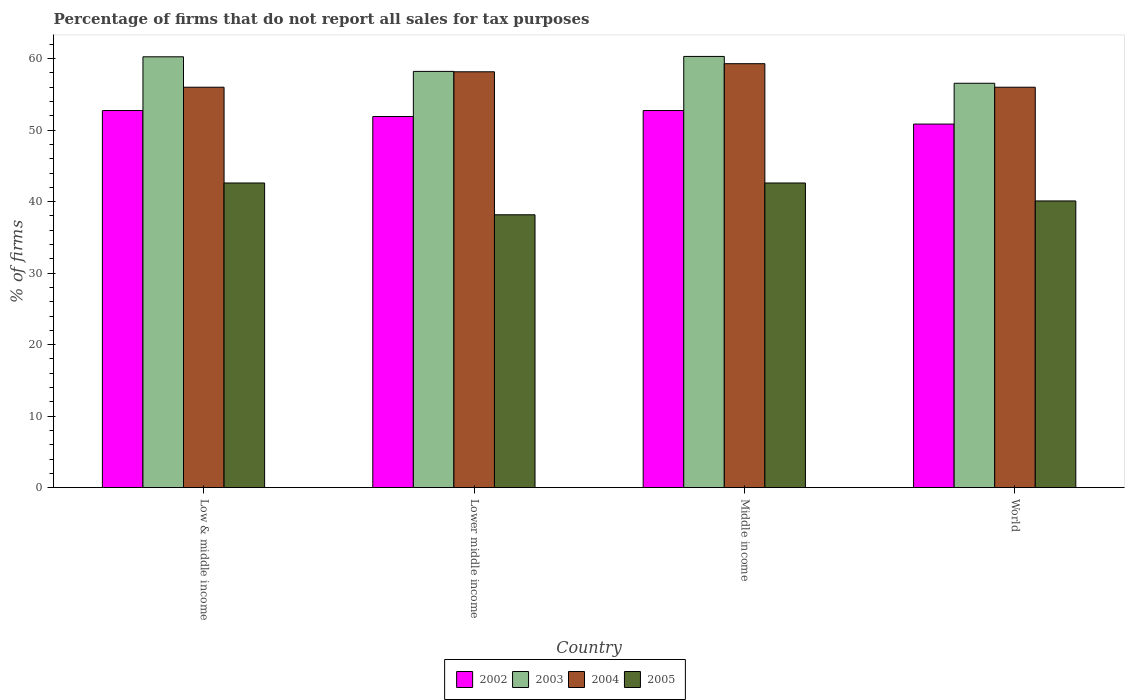How many groups of bars are there?
Ensure brevity in your answer.  4. Are the number of bars per tick equal to the number of legend labels?
Ensure brevity in your answer.  Yes. Are the number of bars on each tick of the X-axis equal?
Keep it short and to the point. Yes. How many bars are there on the 4th tick from the left?
Provide a short and direct response. 4. What is the label of the 2nd group of bars from the left?
Offer a very short reply. Lower middle income. In how many cases, is the number of bars for a given country not equal to the number of legend labels?
Your response must be concise. 0. What is the percentage of firms that do not report all sales for tax purposes in 2002 in Low & middle income?
Your answer should be very brief. 52.75. Across all countries, what is the maximum percentage of firms that do not report all sales for tax purposes in 2004?
Your answer should be compact. 59.3. Across all countries, what is the minimum percentage of firms that do not report all sales for tax purposes in 2004?
Provide a succinct answer. 56.01. In which country was the percentage of firms that do not report all sales for tax purposes in 2005 maximum?
Provide a short and direct response. Low & middle income. In which country was the percentage of firms that do not report all sales for tax purposes in 2004 minimum?
Your answer should be very brief. Low & middle income. What is the total percentage of firms that do not report all sales for tax purposes in 2003 in the graph?
Your answer should be compact. 235.35. What is the difference between the percentage of firms that do not report all sales for tax purposes in 2005 in Low & middle income and that in Middle income?
Provide a short and direct response. 0. What is the difference between the percentage of firms that do not report all sales for tax purposes in 2004 in Low & middle income and the percentage of firms that do not report all sales for tax purposes in 2003 in World?
Give a very brief answer. -0.55. What is the average percentage of firms that do not report all sales for tax purposes in 2002 per country?
Offer a very short reply. 52.06. What is the difference between the percentage of firms that do not report all sales for tax purposes of/in 2003 and percentage of firms that do not report all sales for tax purposes of/in 2002 in Lower middle income?
Your answer should be very brief. 6.31. In how many countries, is the percentage of firms that do not report all sales for tax purposes in 2005 greater than 20 %?
Your answer should be very brief. 4. What is the ratio of the percentage of firms that do not report all sales for tax purposes in 2002 in Lower middle income to that in Middle income?
Offer a very short reply. 0.98. Is the percentage of firms that do not report all sales for tax purposes in 2003 in Middle income less than that in World?
Keep it short and to the point. No. Is the difference between the percentage of firms that do not report all sales for tax purposes in 2003 in Middle income and World greater than the difference between the percentage of firms that do not report all sales for tax purposes in 2002 in Middle income and World?
Ensure brevity in your answer.  Yes. What is the difference between the highest and the second highest percentage of firms that do not report all sales for tax purposes in 2004?
Make the answer very short. -2.16. What is the difference between the highest and the lowest percentage of firms that do not report all sales for tax purposes in 2002?
Provide a short and direct response. 1.89. Is the sum of the percentage of firms that do not report all sales for tax purposes in 2005 in Low & middle income and Lower middle income greater than the maximum percentage of firms that do not report all sales for tax purposes in 2004 across all countries?
Offer a very short reply. Yes. Is it the case that in every country, the sum of the percentage of firms that do not report all sales for tax purposes in 2002 and percentage of firms that do not report all sales for tax purposes in 2005 is greater than the percentage of firms that do not report all sales for tax purposes in 2004?
Your answer should be very brief. Yes. How many bars are there?
Provide a succinct answer. 16. Does the graph contain grids?
Ensure brevity in your answer.  No. What is the title of the graph?
Keep it short and to the point. Percentage of firms that do not report all sales for tax purposes. Does "2001" appear as one of the legend labels in the graph?
Ensure brevity in your answer.  No. What is the label or title of the Y-axis?
Give a very brief answer. % of firms. What is the % of firms in 2002 in Low & middle income?
Your response must be concise. 52.75. What is the % of firms of 2003 in Low & middle income?
Your answer should be compact. 60.26. What is the % of firms of 2004 in Low & middle income?
Your answer should be very brief. 56.01. What is the % of firms in 2005 in Low & middle income?
Give a very brief answer. 42.61. What is the % of firms of 2002 in Lower middle income?
Your answer should be very brief. 51.91. What is the % of firms of 2003 in Lower middle income?
Offer a terse response. 58.22. What is the % of firms in 2004 in Lower middle income?
Your response must be concise. 58.16. What is the % of firms in 2005 in Lower middle income?
Keep it short and to the point. 38.16. What is the % of firms in 2002 in Middle income?
Your answer should be very brief. 52.75. What is the % of firms of 2003 in Middle income?
Ensure brevity in your answer.  60.31. What is the % of firms of 2004 in Middle income?
Your answer should be compact. 59.3. What is the % of firms in 2005 in Middle income?
Make the answer very short. 42.61. What is the % of firms of 2002 in World?
Keep it short and to the point. 50.85. What is the % of firms in 2003 in World?
Provide a succinct answer. 56.56. What is the % of firms in 2004 in World?
Ensure brevity in your answer.  56.01. What is the % of firms in 2005 in World?
Offer a terse response. 40.1. Across all countries, what is the maximum % of firms of 2002?
Your answer should be compact. 52.75. Across all countries, what is the maximum % of firms in 2003?
Your response must be concise. 60.31. Across all countries, what is the maximum % of firms in 2004?
Your answer should be compact. 59.3. Across all countries, what is the maximum % of firms of 2005?
Keep it short and to the point. 42.61. Across all countries, what is the minimum % of firms of 2002?
Your answer should be very brief. 50.85. Across all countries, what is the minimum % of firms of 2003?
Offer a very short reply. 56.56. Across all countries, what is the minimum % of firms of 2004?
Offer a very short reply. 56.01. Across all countries, what is the minimum % of firms in 2005?
Keep it short and to the point. 38.16. What is the total % of firms in 2002 in the graph?
Offer a terse response. 208.25. What is the total % of firms of 2003 in the graph?
Provide a succinct answer. 235.35. What is the total % of firms of 2004 in the graph?
Your response must be concise. 229.47. What is the total % of firms of 2005 in the graph?
Give a very brief answer. 163.48. What is the difference between the % of firms in 2002 in Low & middle income and that in Lower middle income?
Ensure brevity in your answer.  0.84. What is the difference between the % of firms in 2003 in Low & middle income and that in Lower middle income?
Give a very brief answer. 2.04. What is the difference between the % of firms of 2004 in Low & middle income and that in Lower middle income?
Provide a succinct answer. -2.16. What is the difference between the % of firms in 2005 in Low & middle income and that in Lower middle income?
Keep it short and to the point. 4.45. What is the difference between the % of firms in 2002 in Low & middle income and that in Middle income?
Offer a terse response. 0. What is the difference between the % of firms of 2003 in Low & middle income and that in Middle income?
Give a very brief answer. -0.05. What is the difference between the % of firms in 2004 in Low & middle income and that in Middle income?
Ensure brevity in your answer.  -3.29. What is the difference between the % of firms of 2005 in Low & middle income and that in Middle income?
Your response must be concise. 0. What is the difference between the % of firms in 2002 in Low & middle income and that in World?
Make the answer very short. 1.89. What is the difference between the % of firms of 2005 in Low & middle income and that in World?
Make the answer very short. 2.51. What is the difference between the % of firms of 2002 in Lower middle income and that in Middle income?
Keep it short and to the point. -0.84. What is the difference between the % of firms in 2003 in Lower middle income and that in Middle income?
Offer a very short reply. -2.09. What is the difference between the % of firms of 2004 in Lower middle income and that in Middle income?
Your answer should be very brief. -1.13. What is the difference between the % of firms in 2005 in Lower middle income and that in Middle income?
Make the answer very short. -4.45. What is the difference between the % of firms of 2002 in Lower middle income and that in World?
Offer a very short reply. 1.06. What is the difference between the % of firms of 2003 in Lower middle income and that in World?
Provide a short and direct response. 1.66. What is the difference between the % of firms in 2004 in Lower middle income and that in World?
Ensure brevity in your answer.  2.16. What is the difference between the % of firms of 2005 in Lower middle income and that in World?
Provide a short and direct response. -1.94. What is the difference between the % of firms in 2002 in Middle income and that in World?
Offer a terse response. 1.89. What is the difference between the % of firms of 2003 in Middle income and that in World?
Keep it short and to the point. 3.75. What is the difference between the % of firms of 2004 in Middle income and that in World?
Keep it short and to the point. 3.29. What is the difference between the % of firms in 2005 in Middle income and that in World?
Make the answer very short. 2.51. What is the difference between the % of firms of 2002 in Low & middle income and the % of firms of 2003 in Lower middle income?
Make the answer very short. -5.47. What is the difference between the % of firms in 2002 in Low & middle income and the % of firms in 2004 in Lower middle income?
Make the answer very short. -5.42. What is the difference between the % of firms of 2002 in Low & middle income and the % of firms of 2005 in Lower middle income?
Provide a short and direct response. 14.58. What is the difference between the % of firms of 2003 in Low & middle income and the % of firms of 2004 in Lower middle income?
Provide a short and direct response. 2.1. What is the difference between the % of firms in 2003 in Low & middle income and the % of firms in 2005 in Lower middle income?
Your answer should be compact. 22.1. What is the difference between the % of firms in 2004 in Low & middle income and the % of firms in 2005 in Lower middle income?
Offer a terse response. 17.84. What is the difference between the % of firms of 2002 in Low & middle income and the % of firms of 2003 in Middle income?
Offer a terse response. -7.57. What is the difference between the % of firms in 2002 in Low & middle income and the % of firms in 2004 in Middle income?
Make the answer very short. -6.55. What is the difference between the % of firms in 2002 in Low & middle income and the % of firms in 2005 in Middle income?
Ensure brevity in your answer.  10.13. What is the difference between the % of firms in 2003 in Low & middle income and the % of firms in 2004 in Middle income?
Provide a short and direct response. 0.96. What is the difference between the % of firms of 2003 in Low & middle income and the % of firms of 2005 in Middle income?
Your answer should be compact. 17.65. What is the difference between the % of firms of 2004 in Low & middle income and the % of firms of 2005 in Middle income?
Provide a succinct answer. 13.39. What is the difference between the % of firms in 2002 in Low & middle income and the % of firms in 2003 in World?
Your response must be concise. -3.81. What is the difference between the % of firms in 2002 in Low & middle income and the % of firms in 2004 in World?
Make the answer very short. -3.26. What is the difference between the % of firms in 2002 in Low & middle income and the % of firms in 2005 in World?
Your response must be concise. 12.65. What is the difference between the % of firms of 2003 in Low & middle income and the % of firms of 2004 in World?
Ensure brevity in your answer.  4.25. What is the difference between the % of firms of 2003 in Low & middle income and the % of firms of 2005 in World?
Offer a terse response. 20.16. What is the difference between the % of firms of 2004 in Low & middle income and the % of firms of 2005 in World?
Offer a very short reply. 15.91. What is the difference between the % of firms in 2002 in Lower middle income and the % of firms in 2003 in Middle income?
Offer a very short reply. -8.4. What is the difference between the % of firms in 2002 in Lower middle income and the % of firms in 2004 in Middle income?
Your answer should be compact. -7.39. What is the difference between the % of firms in 2002 in Lower middle income and the % of firms in 2005 in Middle income?
Your answer should be compact. 9.3. What is the difference between the % of firms of 2003 in Lower middle income and the % of firms of 2004 in Middle income?
Keep it short and to the point. -1.08. What is the difference between the % of firms in 2003 in Lower middle income and the % of firms in 2005 in Middle income?
Make the answer very short. 15.61. What is the difference between the % of firms in 2004 in Lower middle income and the % of firms in 2005 in Middle income?
Provide a short and direct response. 15.55. What is the difference between the % of firms in 2002 in Lower middle income and the % of firms in 2003 in World?
Give a very brief answer. -4.65. What is the difference between the % of firms in 2002 in Lower middle income and the % of firms in 2004 in World?
Your response must be concise. -4.1. What is the difference between the % of firms of 2002 in Lower middle income and the % of firms of 2005 in World?
Ensure brevity in your answer.  11.81. What is the difference between the % of firms in 2003 in Lower middle income and the % of firms in 2004 in World?
Provide a succinct answer. 2.21. What is the difference between the % of firms of 2003 in Lower middle income and the % of firms of 2005 in World?
Your answer should be very brief. 18.12. What is the difference between the % of firms in 2004 in Lower middle income and the % of firms in 2005 in World?
Offer a terse response. 18.07. What is the difference between the % of firms in 2002 in Middle income and the % of firms in 2003 in World?
Offer a very short reply. -3.81. What is the difference between the % of firms of 2002 in Middle income and the % of firms of 2004 in World?
Ensure brevity in your answer.  -3.26. What is the difference between the % of firms in 2002 in Middle income and the % of firms in 2005 in World?
Provide a succinct answer. 12.65. What is the difference between the % of firms of 2003 in Middle income and the % of firms of 2004 in World?
Give a very brief answer. 4.31. What is the difference between the % of firms in 2003 in Middle income and the % of firms in 2005 in World?
Your response must be concise. 20.21. What is the difference between the % of firms of 2004 in Middle income and the % of firms of 2005 in World?
Your response must be concise. 19.2. What is the average % of firms of 2002 per country?
Offer a terse response. 52.06. What is the average % of firms in 2003 per country?
Give a very brief answer. 58.84. What is the average % of firms in 2004 per country?
Provide a succinct answer. 57.37. What is the average % of firms in 2005 per country?
Provide a short and direct response. 40.87. What is the difference between the % of firms in 2002 and % of firms in 2003 in Low & middle income?
Provide a short and direct response. -7.51. What is the difference between the % of firms in 2002 and % of firms in 2004 in Low & middle income?
Offer a very short reply. -3.26. What is the difference between the % of firms of 2002 and % of firms of 2005 in Low & middle income?
Provide a short and direct response. 10.13. What is the difference between the % of firms of 2003 and % of firms of 2004 in Low & middle income?
Offer a terse response. 4.25. What is the difference between the % of firms in 2003 and % of firms in 2005 in Low & middle income?
Give a very brief answer. 17.65. What is the difference between the % of firms in 2004 and % of firms in 2005 in Low & middle income?
Your response must be concise. 13.39. What is the difference between the % of firms in 2002 and % of firms in 2003 in Lower middle income?
Offer a very short reply. -6.31. What is the difference between the % of firms in 2002 and % of firms in 2004 in Lower middle income?
Offer a very short reply. -6.26. What is the difference between the % of firms in 2002 and % of firms in 2005 in Lower middle income?
Give a very brief answer. 13.75. What is the difference between the % of firms of 2003 and % of firms of 2004 in Lower middle income?
Offer a terse response. 0.05. What is the difference between the % of firms of 2003 and % of firms of 2005 in Lower middle income?
Offer a terse response. 20.06. What is the difference between the % of firms of 2004 and % of firms of 2005 in Lower middle income?
Your answer should be compact. 20. What is the difference between the % of firms in 2002 and % of firms in 2003 in Middle income?
Offer a very short reply. -7.57. What is the difference between the % of firms in 2002 and % of firms in 2004 in Middle income?
Provide a succinct answer. -6.55. What is the difference between the % of firms of 2002 and % of firms of 2005 in Middle income?
Ensure brevity in your answer.  10.13. What is the difference between the % of firms of 2003 and % of firms of 2004 in Middle income?
Provide a short and direct response. 1.02. What is the difference between the % of firms of 2003 and % of firms of 2005 in Middle income?
Offer a very short reply. 17.7. What is the difference between the % of firms of 2004 and % of firms of 2005 in Middle income?
Provide a short and direct response. 16.69. What is the difference between the % of firms in 2002 and % of firms in 2003 in World?
Offer a terse response. -5.71. What is the difference between the % of firms of 2002 and % of firms of 2004 in World?
Provide a succinct answer. -5.15. What is the difference between the % of firms of 2002 and % of firms of 2005 in World?
Provide a short and direct response. 10.75. What is the difference between the % of firms in 2003 and % of firms in 2004 in World?
Make the answer very short. 0.56. What is the difference between the % of firms in 2003 and % of firms in 2005 in World?
Make the answer very short. 16.46. What is the difference between the % of firms of 2004 and % of firms of 2005 in World?
Keep it short and to the point. 15.91. What is the ratio of the % of firms of 2002 in Low & middle income to that in Lower middle income?
Give a very brief answer. 1.02. What is the ratio of the % of firms in 2003 in Low & middle income to that in Lower middle income?
Make the answer very short. 1.04. What is the ratio of the % of firms of 2004 in Low & middle income to that in Lower middle income?
Provide a short and direct response. 0.96. What is the ratio of the % of firms in 2005 in Low & middle income to that in Lower middle income?
Give a very brief answer. 1.12. What is the ratio of the % of firms in 2002 in Low & middle income to that in Middle income?
Provide a short and direct response. 1. What is the ratio of the % of firms of 2004 in Low & middle income to that in Middle income?
Your answer should be compact. 0.94. What is the ratio of the % of firms in 2002 in Low & middle income to that in World?
Offer a terse response. 1.04. What is the ratio of the % of firms of 2003 in Low & middle income to that in World?
Give a very brief answer. 1.07. What is the ratio of the % of firms of 2005 in Low & middle income to that in World?
Give a very brief answer. 1.06. What is the ratio of the % of firms in 2002 in Lower middle income to that in Middle income?
Ensure brevity in your answer.  0.98. What is the ratio of the % of firms of 2003 in Lower middle income to that in Middle income?
Offer a terse response. 0.97. What is the ratio of the % of firms of 2004 in Lower middle income to that in Middle income?
Ensure brevity in your answer.  0.98. What is the ratio of the % of firms in 2005 in Lower middle income to that in Middle income?
Your response must be concise. 0.9. What is the ratio of the % of firms in 2002 in Lower middle income to that in World?
Keep it short and to the point. 1.02. What is the ratio of the % of firms of 2003 in Lower middle income to that in World?
Ensure brevity in your answer.  1.03. What is the ratio of the % of firms in 2004 in Lower middle income to that in World?
Provide a succinct answer. 1.04. What is the ratio of the % of firms in 2005 in Lower middle income to that in World?
Offer a very short reply. 0.95. What is the ratio of the % of firms of 2002 in Middle income to that in World?
Your answer should be very brief. 1.04. What is the ratio of the % of firms of 2003 in Middle income to that in World?
Keep it short and to the point. 1.07. What is the ratio of the % of firms in 2004 in Middle income to that in World?
Make the answer very short. 1.06. What is the ratio of the % of firms in 2005 in Middle income to that in World?
Your answer should be compact. 1.06. What is the difference between the highest and the second highest % of firms of 2002?
Make the answer very short. 0. What is the difference between the highest and the second highest % of firms in 2003?
Your response must be concise. 0.05. What is the difference between the highest and the second highest % of firms of 2004?
Provide a short and direct response. 1.13. What is the difference between the highest and the second highest % of firms in 2005?
Ensure brevity in your answer.  0. What is the difference between the highest and the lowest % of firms in 2002?
Give a very brief answer. 1.89. What is the difference between the highest and the lowest % of firms of 2003?
Keep it short and to the point. 3.75. What is the difference between the highest and the lowest % of firms of 2004?
Provide a succinct answer. 3.29. What is the difference between the highest and the lowest % of firms in 2005?
Your answer should be compact. 4.45. 